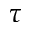<formula> <loc_0><loc_0><loc_500><loc_500>\tau</formula> 